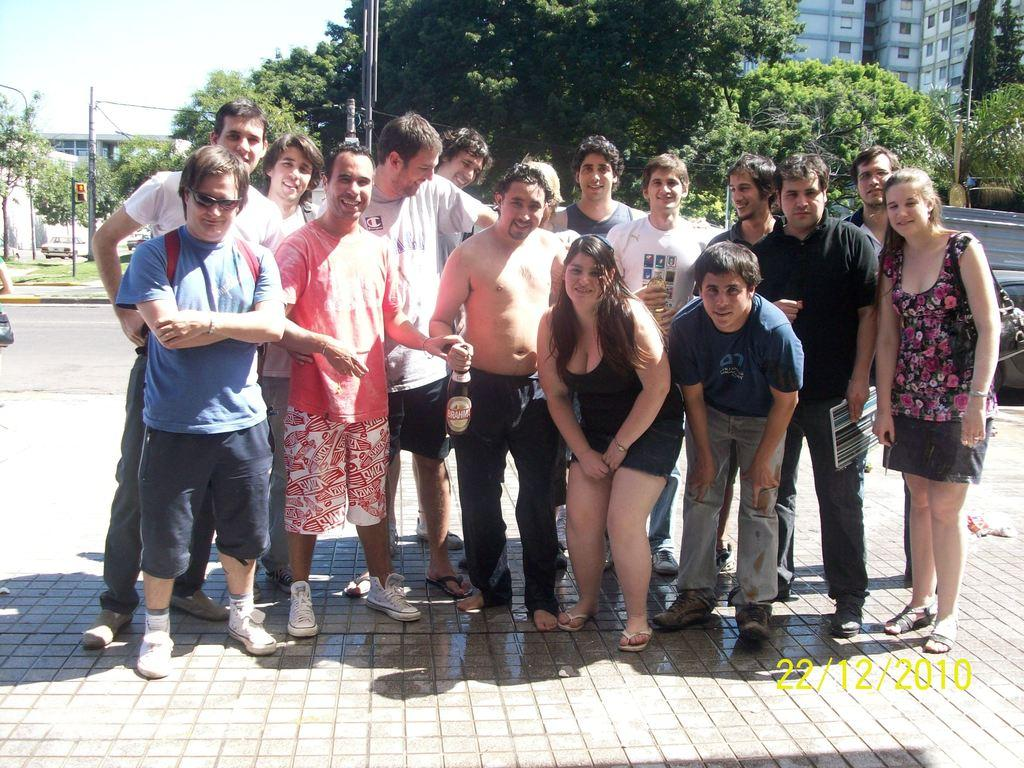What types of people are present in the image? There are men and women in the image. Where are the people located in the image? The people are standing on the floor. What can be seen in the background of the image? There are trees and a building in the background of the image. Is there a stove visible in the image? No, there is no stove present in the image. Can you see any quicksand in the image? No, there is no quicksand present in the image. 